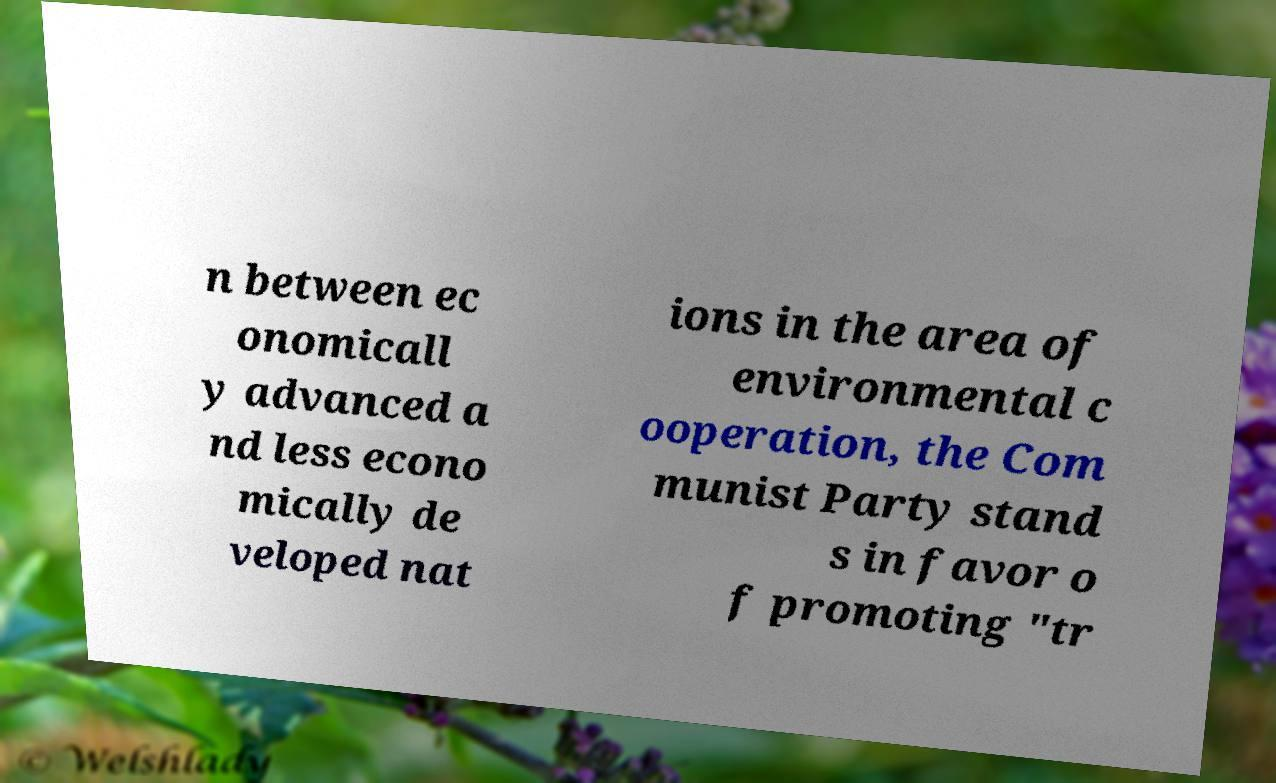Can you accurately transcribe the text from the provided image for me? n between ec onomicall y advanced a nd less econo mically de veloped nat ions in the area of environmental c ooperation, the Com munist Party stand s in favor o f promoting "tr 